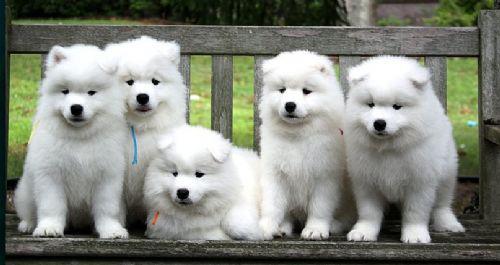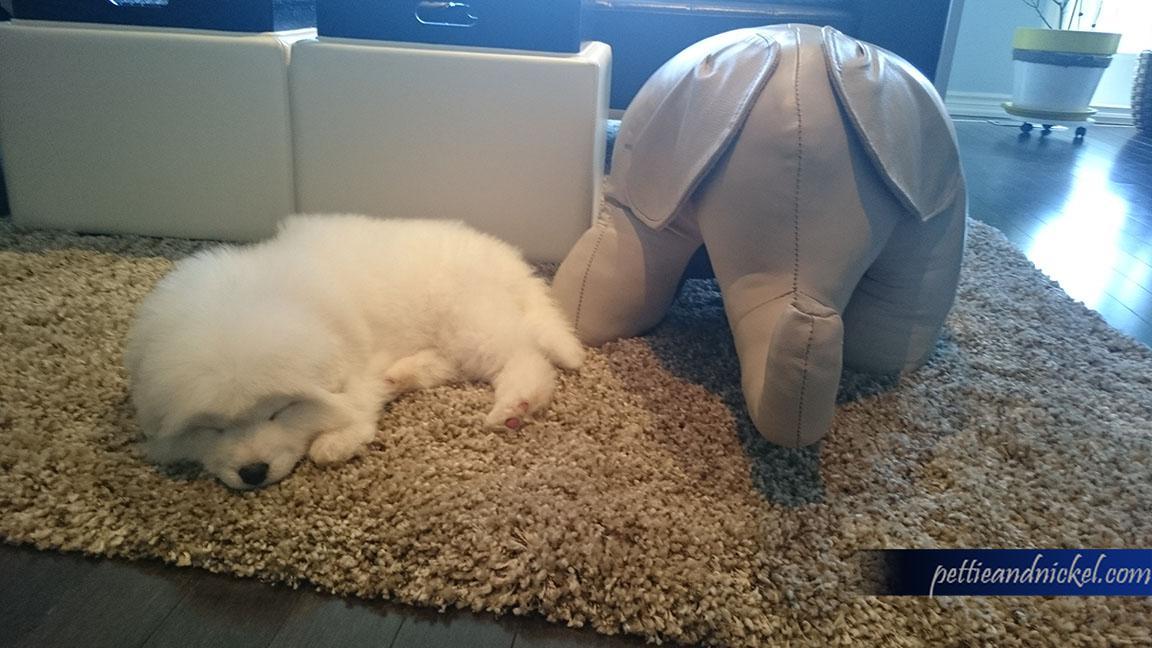The first image is the image on the left, the second image is the image on the right. Considering the images on both sides, is "At least one white dog is standing next to a person's legs." valid? Answer yes or no. No. 